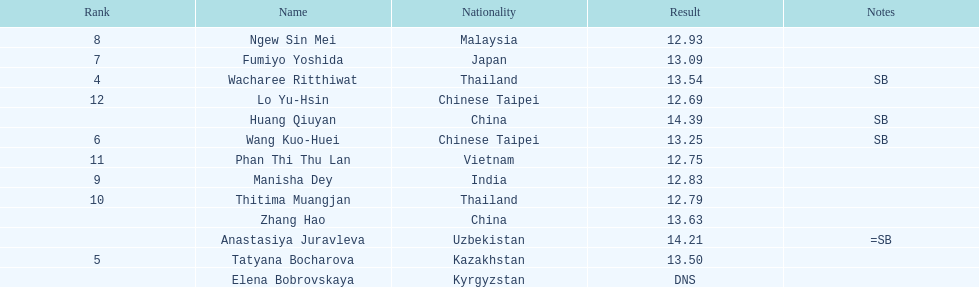What was the average result of the top three jumpers? 14.08. 